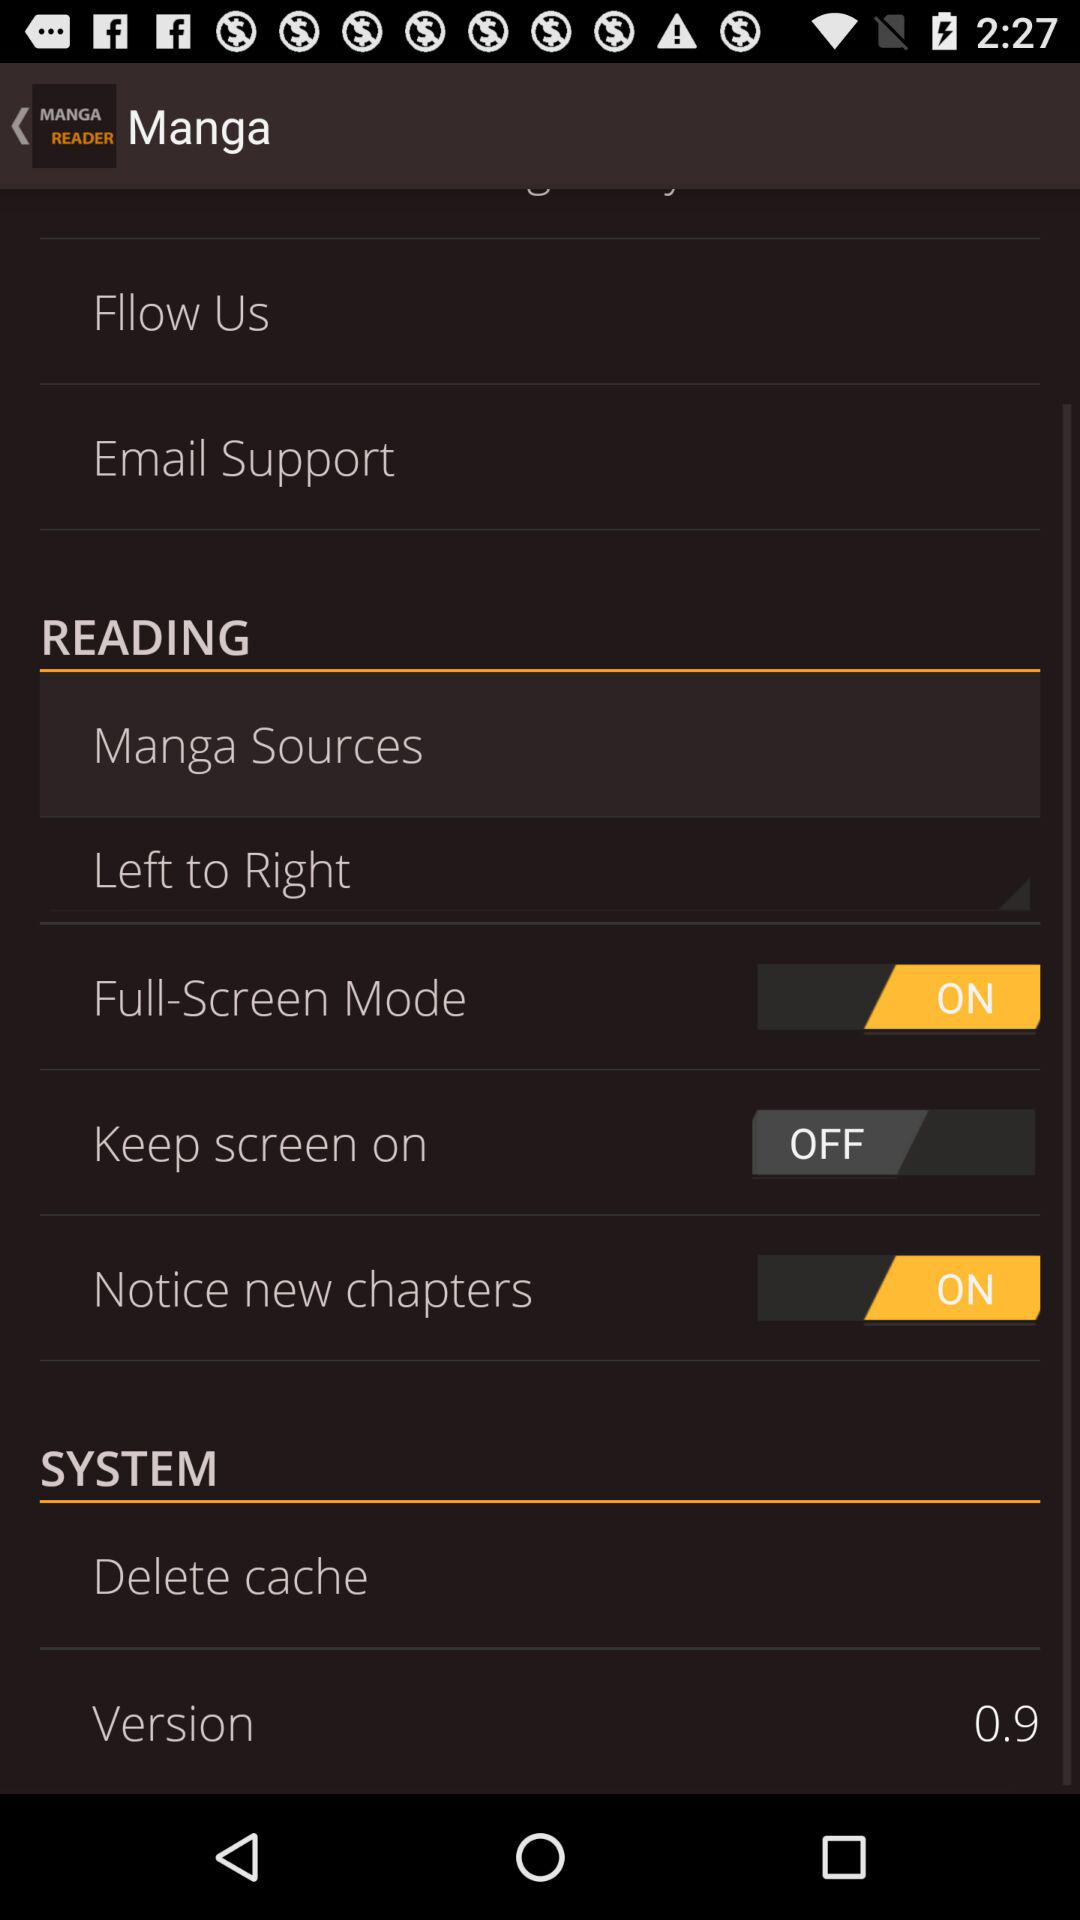What is the status of "Full-Screen Mode"? The status of "Full-Screen Mode" is "on". 